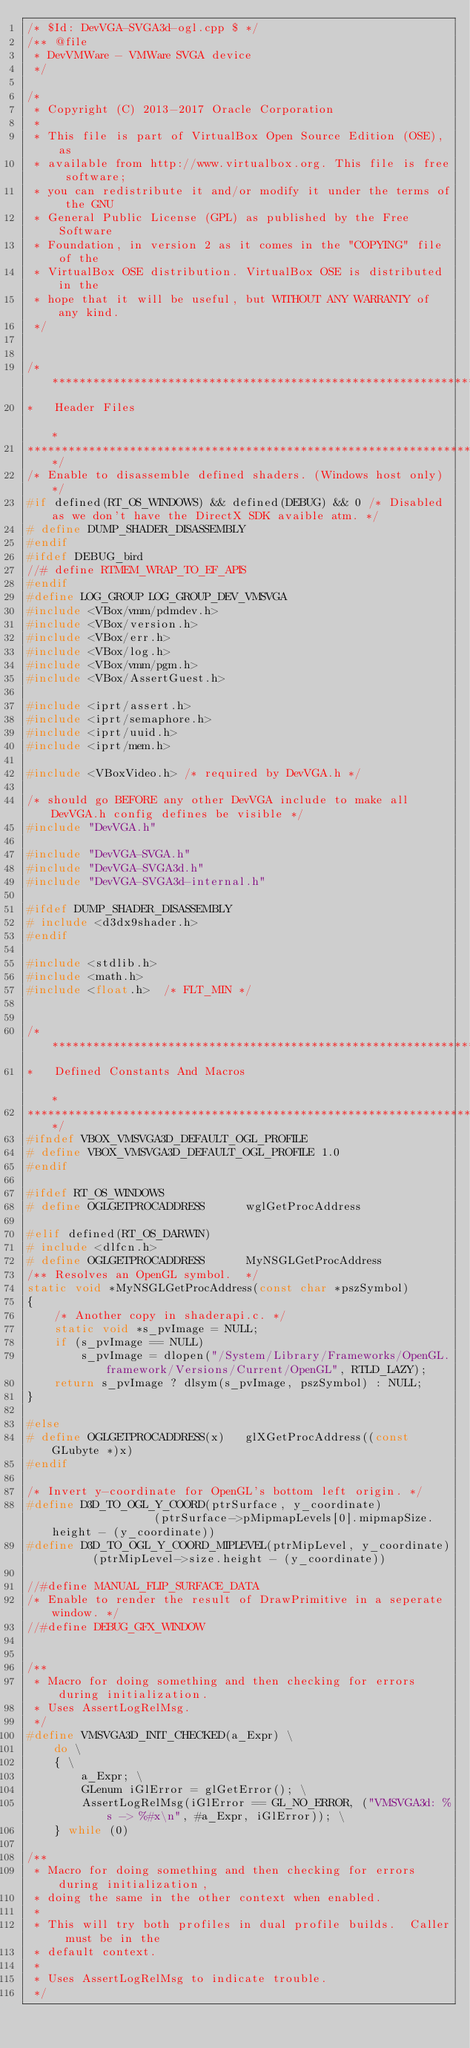Convert code to text. <code><loc_0><loc_0><loc_500><loc_500><_C++_>/* $Id: DevVGA-SVGA3d-ogl.cpp $ */
/** @file
 * DevVMWare - VMWare SVGA device
 */

/*
 * Copyright (C) 2013-2017 Oracle Corporation
 *
 * This file is part of VirtualBox Open Source Edition (OSE), as
 * available from http://www.virtualbox.org. This file is free software;
 * you can redistribute it and/or modify it under the terms of the GNU
 * General Public License (GPL) as published by the Free Software
 * Foundation, in version 2 as it comes in the "COPYING" file of the
 * VirtualBox OSE distribution. VirtualBox OSE is distributed in the
 * hope that it will be useful, but WITHOUT ANY WARRANTY of any kind.
 */


/*********************************************************************************************************************************
*   Header Files                                                                                                                 *
*********************************************************************************************************************************/
/* Enable to disassemble defined shaders. (Windows host only) */
#if defined(RT_OS_WINDOWS) && defined(DEBUG) && 0 /* Disabled as we don't have the DirectX SDK avaible atm. */
# define DUMP_SHADER_DISASSEMBLY
#endif
#ifdef DEBUG_bird
//# define RTMEM_WRAP_TO_EF_APIS
#endif
#define LOG_GROUP LOG_GROUP_DEV_VMSVGA
#include <VBox/vmm/pdmdev.h>
#include <VBox/version.h>
#include <VBox/err.h>
#include <VBox/log.h>
#include <VBox/vmm/pgm.h>
#include <VBox/AssertGuest.h>

#include <iprt/assert.h>
#include <iprt/semaphore.h>
#include <iprt/uuid.h>
#include <iprt/mem.h>

#include <VBoxVideo.h> /* required by DevVGA.h */

/* should go BEFORE any other DevVGA include to make all DevVGA.h config defines be visible */
#include "DevVGA.h"

#include "DevVGA-SVGA.h"
#include "DevVGA-SVGA3d.h"
#include "DevVGA-SVGA3d-internal.h"

#ifdef DUMP_SHADER_DISASSEMBLY
# include <d3dx9shader.h>
#endif

#include <stdlib.h>
#include <math.h>
#include <float.h>  /* FLT_MIN */


/*********************************************************************************************************************************
*   Defined Constants And Macros                                                                                                 *
*********************************************************************************************************************************/
#ifndef VBOX_VMSVGA3D_DEFAULT_OGL_PROFILE
# define VBOX_VMSVGA3D_DEFAULT_OGL_PROFILE 1.0
#endif

#ifdef RT_OS_WINDOWS
# define OGLGETPROCADDRESS      wglGetProcAddress

#elif defined(RT_OS_DARWIN)
# include <dlfcn.h>
# define OGLGETPROCADDRESS      MyNSGLGetProcAddress
/** Resolves an OpenGL symbol.  */
static void *MyNSGLGetProcAddress(const char *pszSymbol)
{
    /* Another copy in shaderapi.c. */
    static void *s_pvImage = NULL;
    if (s_pvImage == NULL)
        s_pvImage = dlopen("/System/Library/Frameworks/OpenGL.framework/Versions/Current/OpenGL", RTLD_LAZY);
    return s_pvImage ? dlsym(s_pvImage, pszSymbol) : NULL;
}

#else
# define OGLGETPROCADDRESS(x)   glXGetProcAddress((const GLubyte *)x)
#endif

/* Invert y-coordinate for OpenGL's bottom left origin. */
#define D3D_TO_OGL_Y_COORD(ptrSurface, y_coordinate)                (ptrSurface->pMipmapLevels[0].mipmapSize.height - (y_coordinate))
#define D3D_TO_OGL_Y_COORD_MIPLEVEL(ptrMipLevel, y_coordinate)      (ptrMipLevel->size.height - (y_coordinate))

//#define MANUAL_FLIP_SURFACE_DATA
/* Enable to render the result of DrawPrimitive in a seperate window. */
//#define DEBUG_GFX_WINDOW


/**
 * Macro for doing something and then checking for errors during initialization.
 * Uses AssertLogRelMsg.
 */
#define VMSVGA3D_INIT_CHECKED(a_Expr) \
    do \
    { \
        a_Expr; \
        GLenum iGlError = glGetError(); \
        AssertLogRelMsg(iGlError == GL_NO_ERROR, ("VMSVGA3d: %s -> %#x\n", #a_Expr, iGlError)); \
    } while (0)

/**
 * Macro for doing something and then checking for errors during initialization,
 * doing the same in the other context when enabled.
 *
 * This will try both profiles in dual profile builds.  Caller must be in the
 * default context.
 *
 * Uses AssertLogRelMsg to indicate trouble.
 */</code> 